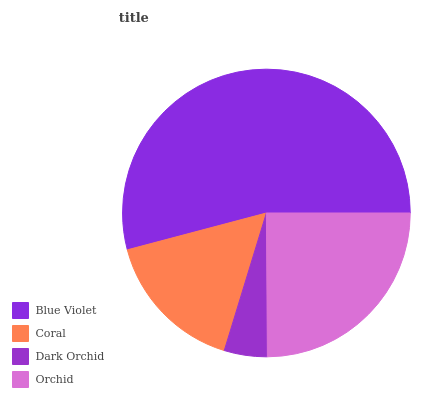Is Dark Orchid the minimum?
Answer yes or no. Yes. Is Blue Violet the maximum?
Answer yes or no. Yes. Is Coral the minimum?
Answer yes or no. No. Is Coral the maximum?
Answer yes or no. No. Is Blue Violet greater than Coral?
Answer yes or no. Yes. Is Coral less than Blue Violet?
Answer yes or no. Yes. Is Coral greater than Blue Violet?
Answer yes or no. No. Is Blue Violet less than Coral?
Answer yes or no. No. Is Orchid the high median?
Answer yes or no. Yes. Is Coral the low median?
Answer yes or no. Yes. Is Coral the high median?
Answer yes or no. No. Is Dark Orchid the low median?
Answer yes or no. No. 